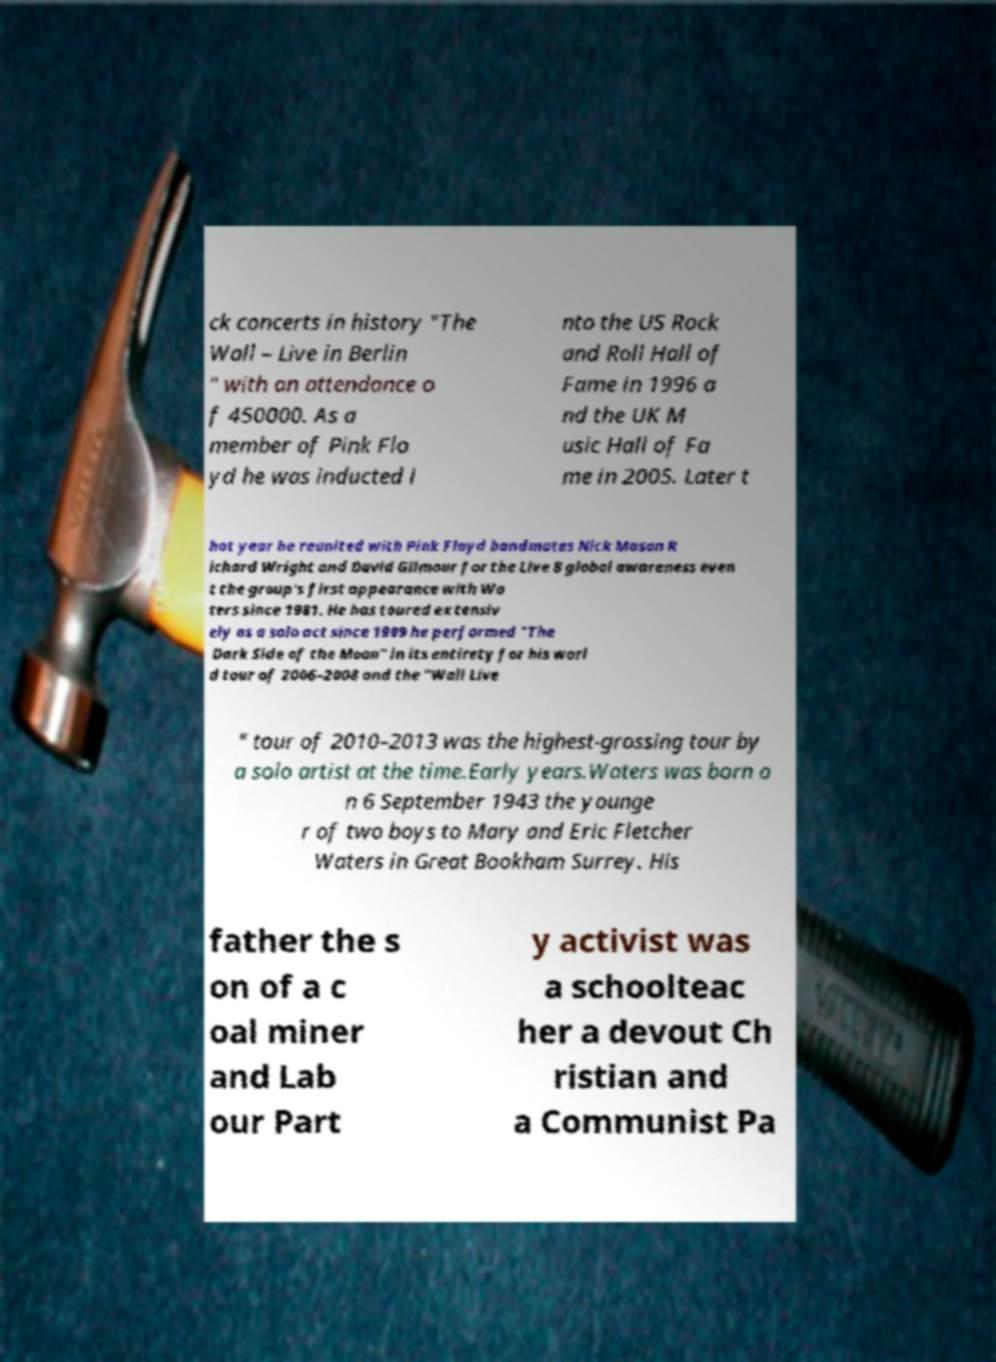There's text embedded in this image that I need extracted. Can you transcribe it verbatim? ck concerts in history "The Wall – Live in Berlin " with an attendance o f 450000. As a member of Pink Flo yd he was inducted i nto the US Rock and Roll Hall of Fame in 1996 a nd the UK M usic Hall of Fa me in 2005. Later t hat year he reunited with Pink Floyd bandmates Nick Mason R ichard Wright and David Gilmour for the Live 8 global awareness even t the group's first appearance with Wa ters since 1981. He has toured extensiv ely as a solo act since 1999 he performed "The Dark Side of the Moon" in its entirety for his worl d tour of 2006–2008 and the "Wall Live " tour of 2010–2013 was the highest-grossing tour by a solo artist at the time.Early years.Waters was born o n 6 September 1943 the younge r of two boys to Mary and Eric Fletcher Waters in Great Bookham Surrey. His father the s on of a c oal miner and Lab our Part y activist was a schoolteac her a devout Ch ristian and a Communist Pa 